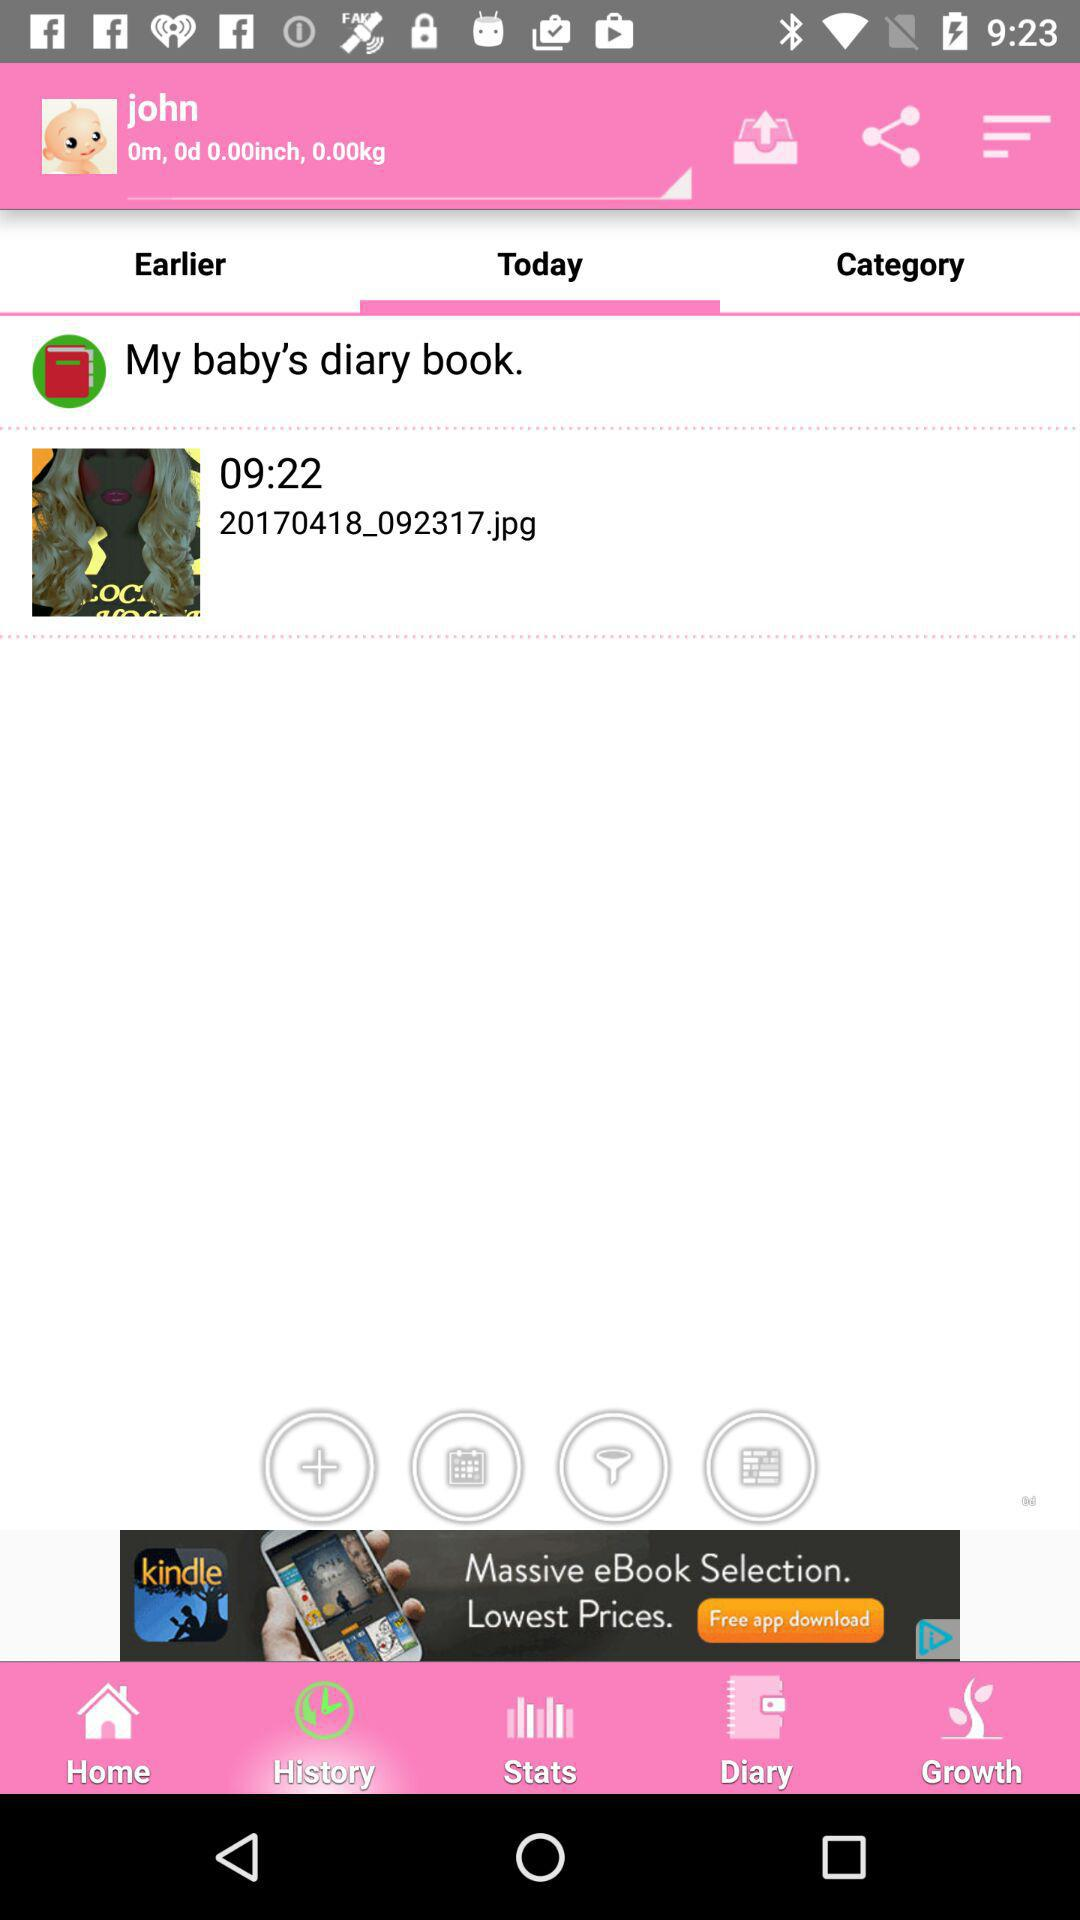What is the time of today's baby diary book? The time is 09:22. 